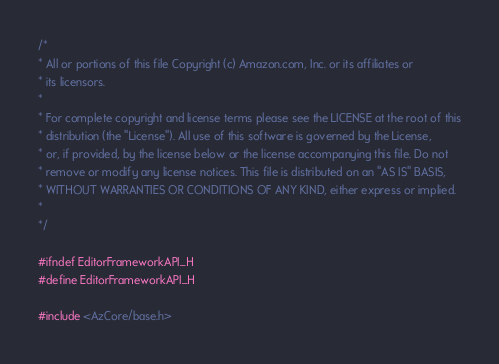Convert code to text. <code><loc_0><loc_0><loc_500><loc_500><_C_>/*
* All or portions of this file Copyright (c) Amazon.com, Inc. or its affiliates or
* its licensors.
*
* For complete copyright and license terms please see the LICENSE at the root of this
* distribution (the "License"). All use of this software is governed by the License,
* or, if provided, by the license below or the license accompanying this file. Do not
* remove or modify any license notices. This file is distributed on an "AS IS" BASIS,
* WITHOUT WARRANTIES OR CONDITIONS OF ANY KIND, either express or implied.
*
*/

#ifndef EditorFrameworkAPI_H
#define EditorFrameworkAPI_H

#include <AzCore/base.h></code> 